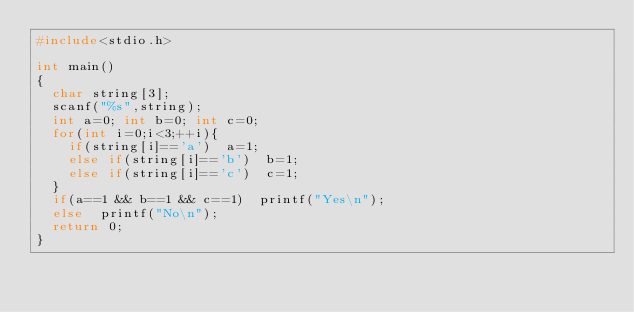<code> <loc_0><loc_0><loc_500><loc_500><_C_>#include<stdio.h>

int main()
{
  char string[3];
  scanf("%s",string);
  int a=0; int b=0; int c=0;
  for(int i=0;i<3;++i){
    if(string[i]=='a')  a=1;
    else if(string[i]=='b')  b=1;
    else if(string[i]=='c')  c=1;
  }
  if(a==1 && b==1 && c==1)  printf("Yes\n");
  else  printf("No\n");
  return 0;
}</code> 